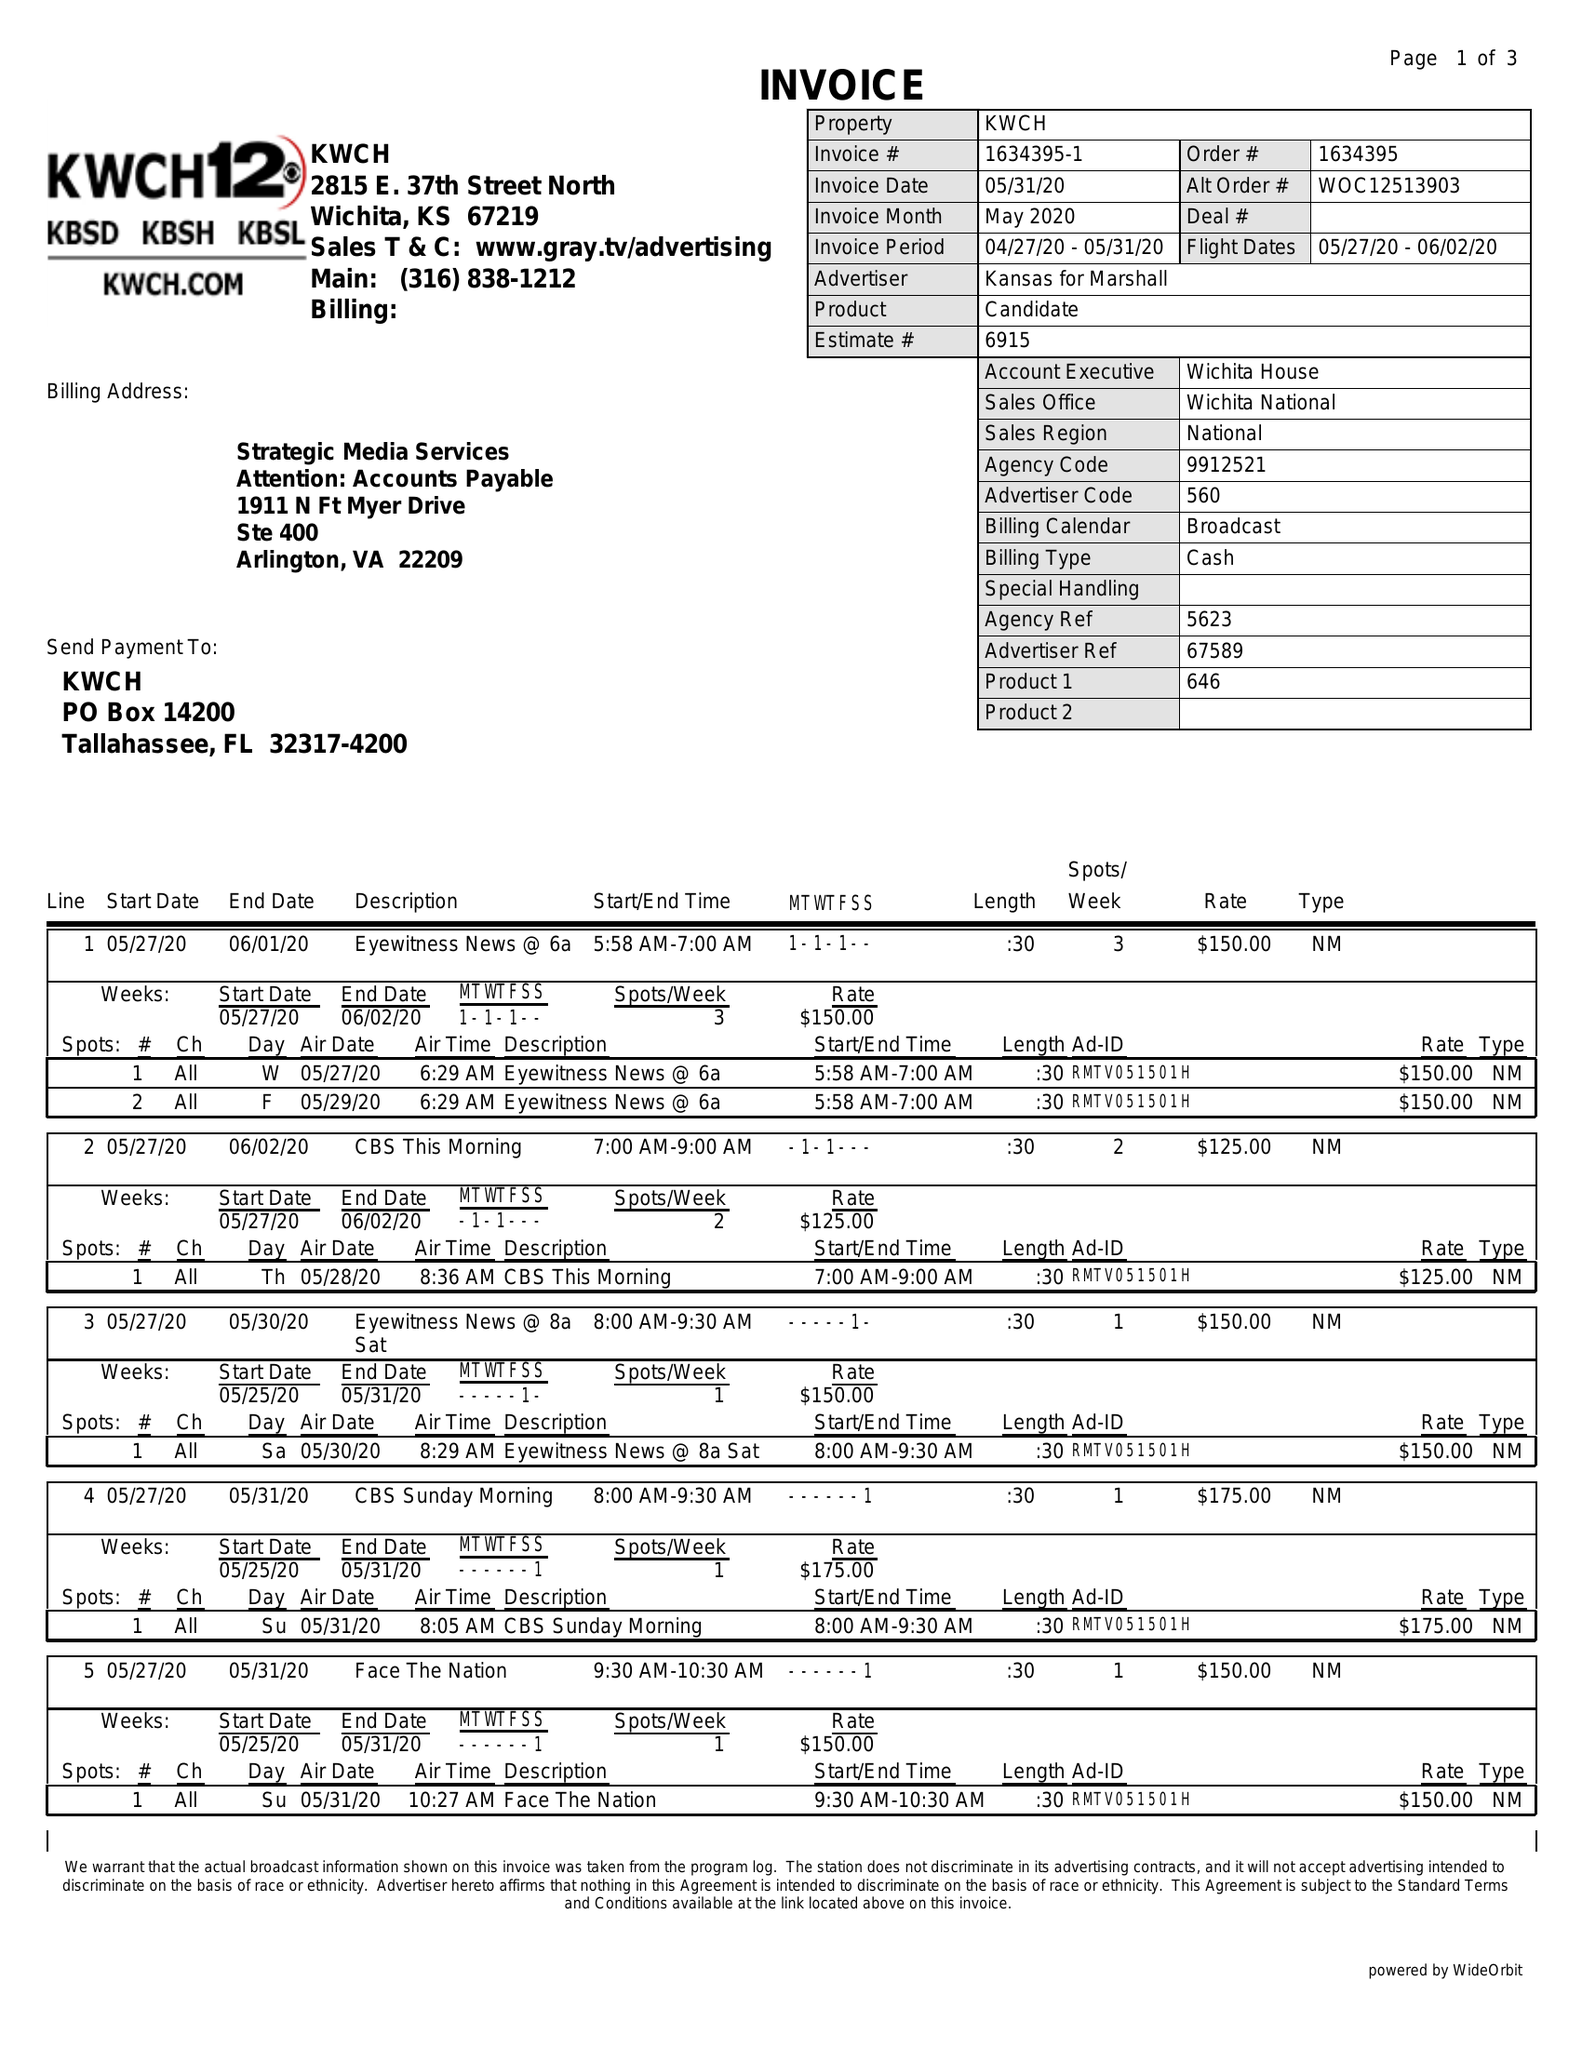What is the value for the flight_from?
Answer the question using a single word or phrase. 05/27/20 